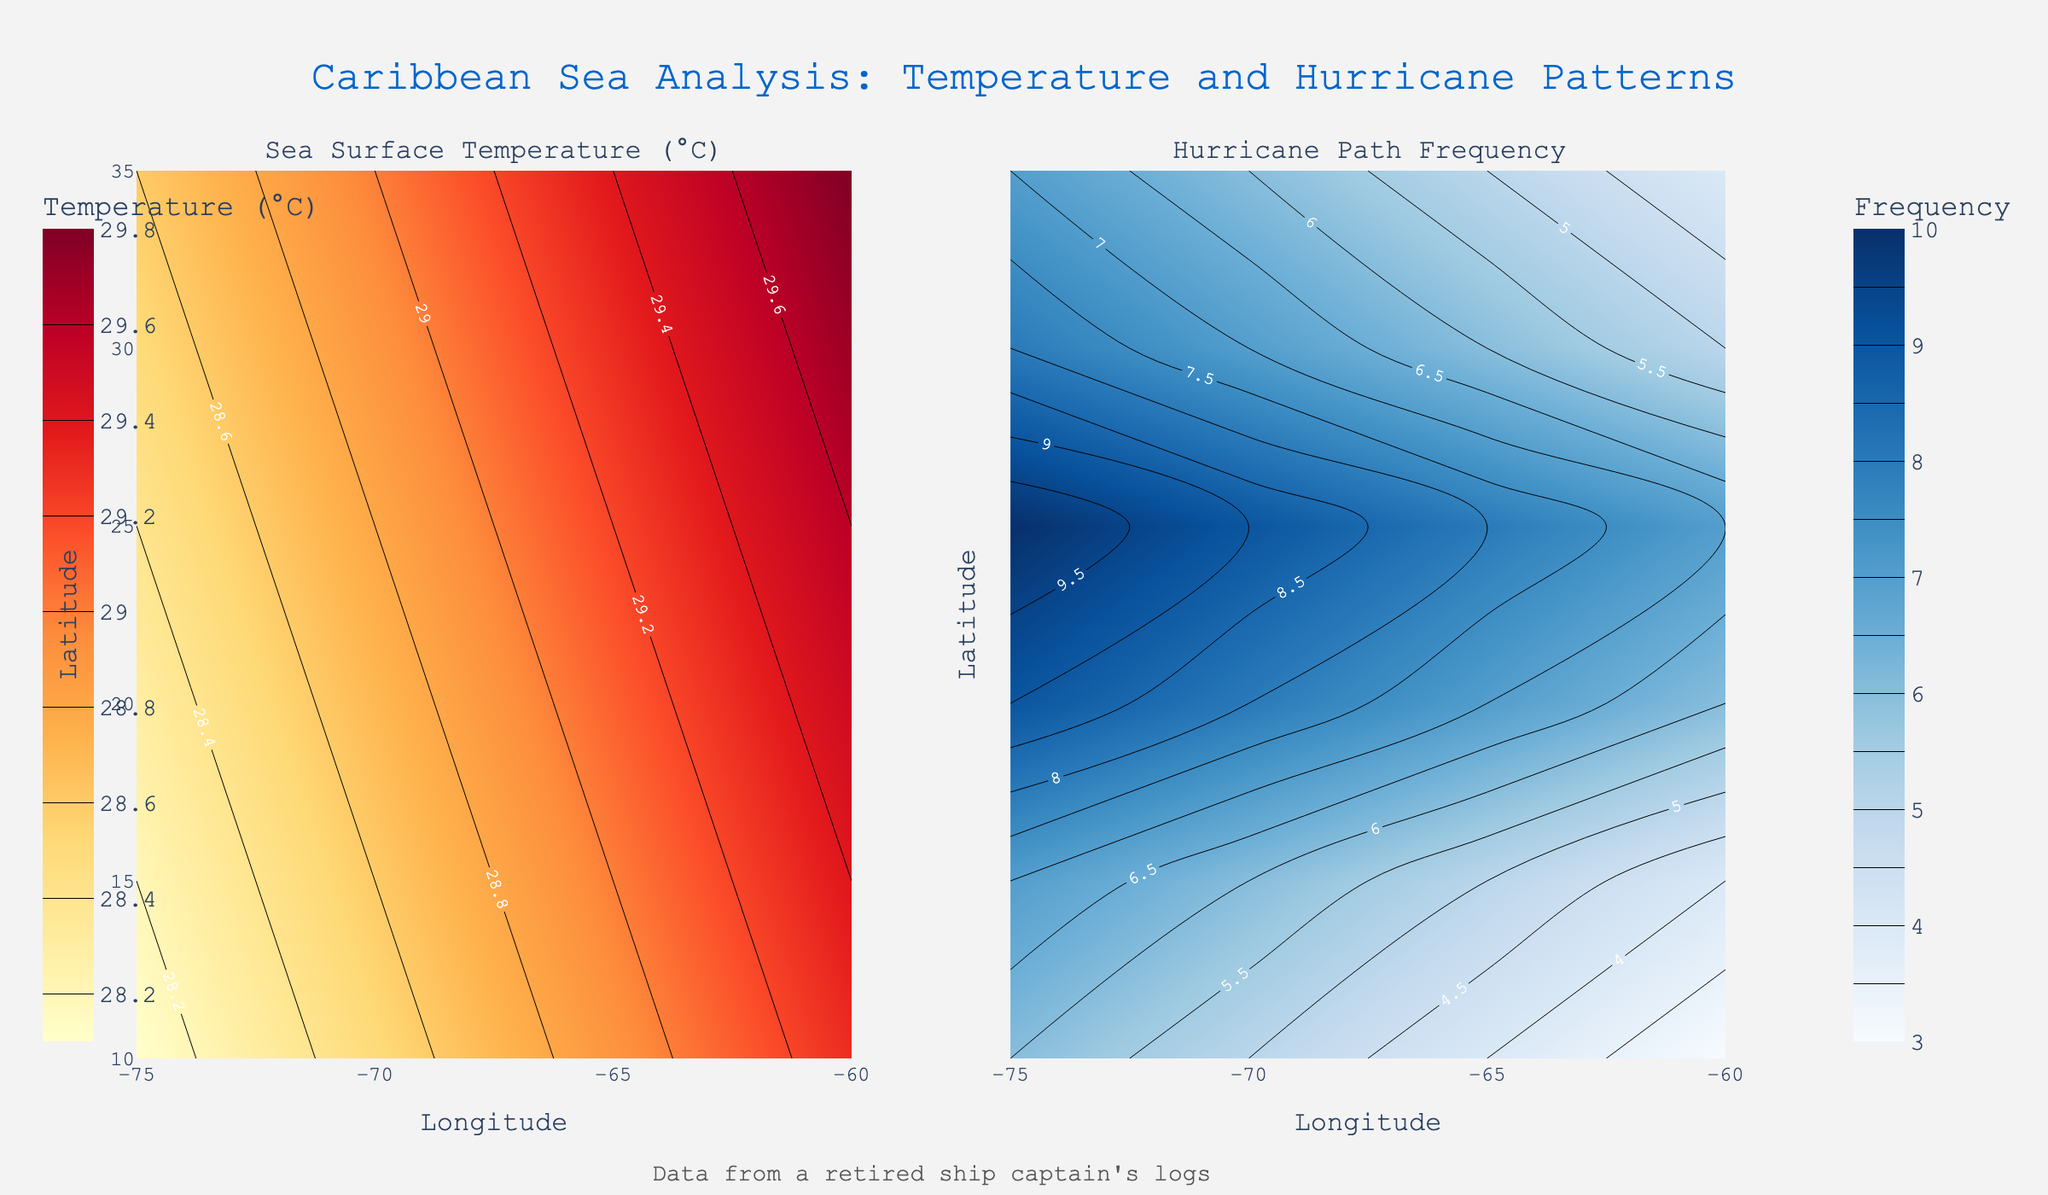What does the left contour plot represent? The left contour plot is labeled "Sea Surface Temperature (°C)" and shows the sea surface temperatures in the Caribbean region.
Answer: Sea surface temperatures What does the right contour plot represent? The right contour plot is labeled "Hurricane Path Frequency" and shows the frequency of hurricane paths in the Caribbean.
Answer: Hurricane path frequency Which latitude-longitude combination shows the highest sea surface temperature? By examining the Sea Surface Temperature contour plot, the highest temperature is in the bottom left, corresponding to 10.0 latitude and -85.0 longitude.
Answer: 10.0, -85.0 At which latitude and longitude do we see the highest hurricane path frequency? The highest frequency is observed in the right plot around the top right corner, at 25.0 latitude and -75.0 longitude.
Answer: 25.0, -75.0 How does sea surface temperature vary from west to east at 10.0 latitude? From the left plot, we observe that temperatures decrease from west (-85.0 longitude, 29.8°C) to east (-60.0 longitude, 29.3°C).
Answer: Decreases Compare the hurricane path frequency between latitudes 15.0 and 25.0 at longitude -75.0. At longitude -75.0, latitude 15.0 has a frequency of 8, while latitude 25.0 has a frequency of 10.
Answer: 25.0 has higher frequency What is the trend in sea surface temperature as you move northward along longitude -70.0? Looking at the left plot, the sea surface temperature decreases as you move from 10.0 latitude (29.5°C) to 25.0 latitude (28.3°C).
Answer: Decreases Is there a correlation between sea surface temperature and hurricane path frequency? By observing both plots, we see that areas with higher sea surface temperatures (29-30°C) generally have higher hurricane path frequencies, indicating a positive correlation.
Answer: Yes, positive correlation What is the color scheme used to represent the sea surface temperatures? The contour plot for sea surface temperatures uses a color scheme ranging from yellow to red.
Answer: Yellow to red What pattern do you observe in hurricane path frequencies concerning longitude? In the right contour plot, hurricane path frequencies generally increase from east (longitude -60.0) to west (longitude -85.0).
Answer: Increases 